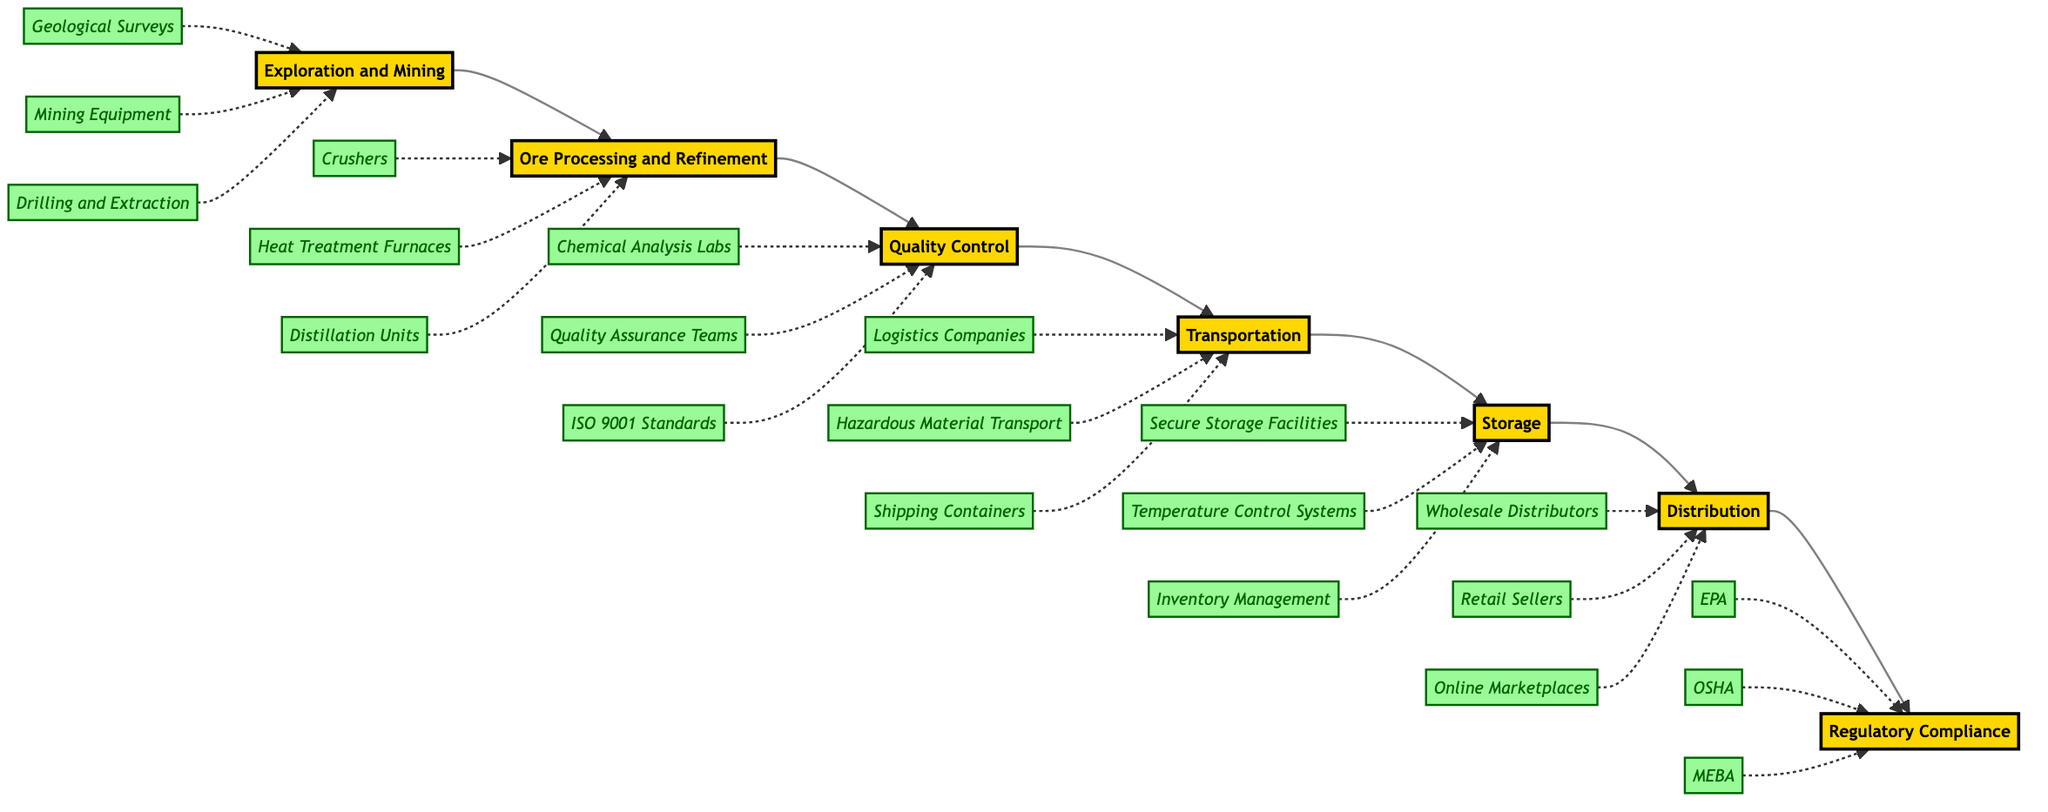What is the first step in the supply chain? The first step in the supply chain is identified as "Exploration and Mining", which is visible as the starting node in the flowchart.
Answer: Exploration and Mining How many steps are there in the supply chain? By counting the nodes involved in the horizontal flowchart, there are 7 distinct steps represented.
Answer: 7 Which step follows Quality Control? The step immediately following "Quality Control" is "Transportation," as indicated by the directed flow to that node.
Answer: Transportation What entities are associated with Ore Processing and Refinement? The associated entities listed under "Ore Processing and Refinement" include "Crushers," "Heat Treatment Furnaces," and "Distillation Units," which can be seen connected by dashed lines.
Answer: Crushers, Heat Treatment Furnaces, Distillation Units Which regulatory bodies are involved in Regulatory Compliance? The entities that are involved in "Regulatory Compliance" include "Environmental Protection Agency (EPA)," "Occupational Safety and Health Administration (OSHA)," and "Mercury Export Ban Act (MEBA)," which are shown as entities under that step.
Answer: EPA, OSHA, MEBA What is the last step in the flow of the supply chain? The last step in the flowchart is "Regulatory Compliance," as it appears at the end of the horizontal sequence, indicating the final step in the supply chain management process.
Answer: Regulatory Compliance How does Transportation relate to Storage? In the flowchart, "Transportation" is directly connected to "Storage," indicating that refined mercury is transported to storage facilities after transportation.
Answer: Directly connected 